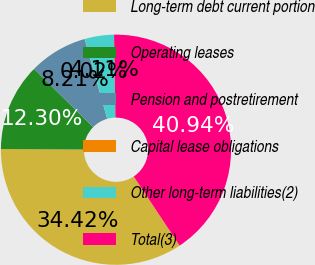Convert chart to OTSL. <chart><loc_0><loc_0><loc_500><loc_500><pie_chart><fcel>Long-term debt current portion<fcel>Operating leases<fcel>Pension and postretirement<fcel>Capital lease obligations<fcel>Other long-term liabilities(2)<fcel>Total(3)<nl><fcel>34.42%<fcel>12.3%<fcel>8.21%<fcel>0.02%<fcel>4.11%<fcel>40.94%<nl></chart> 